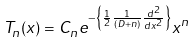Convert formula to latex. <formula><loc_0><loc_0><loc_500><loc_500>T _ { n } ( x ) = C _ { n } e ^ { - \left \{ \frac { 1 } { 2 } \frac { 1 } { ( D + n ) } \frac { d ^ { 2 } } { d x ^ { 2 } } \right \} } x ^ { n }</formula> 